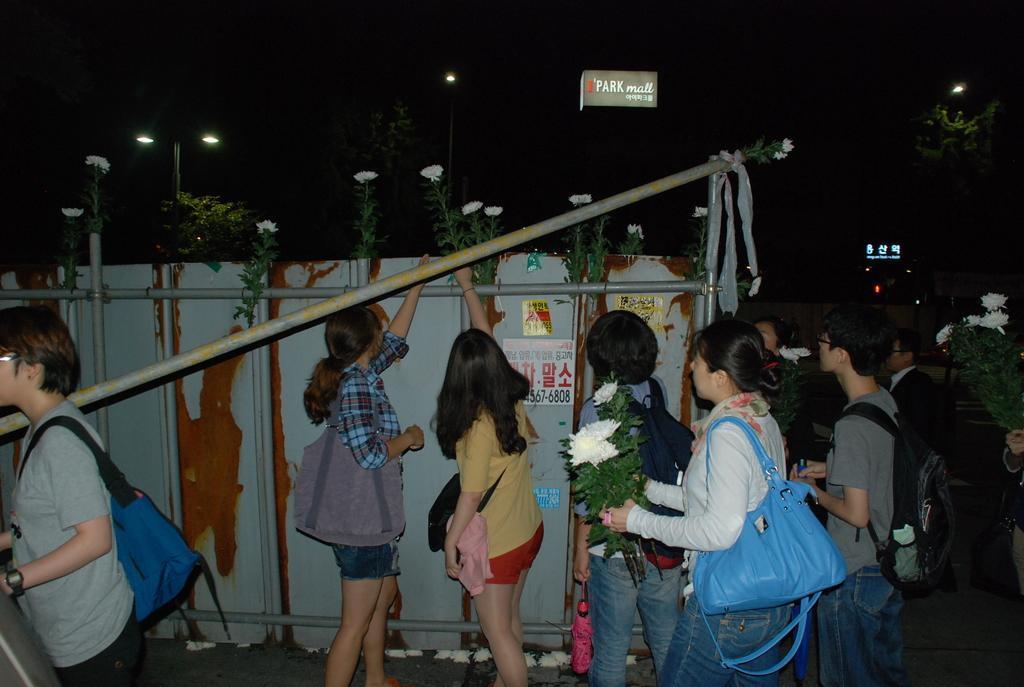Describe this image in one or two sentences. In this picture we can see a group of people standing on the road, bags, flowers, rods, poster, umbrella, name board, lights and in the background it is dark. 